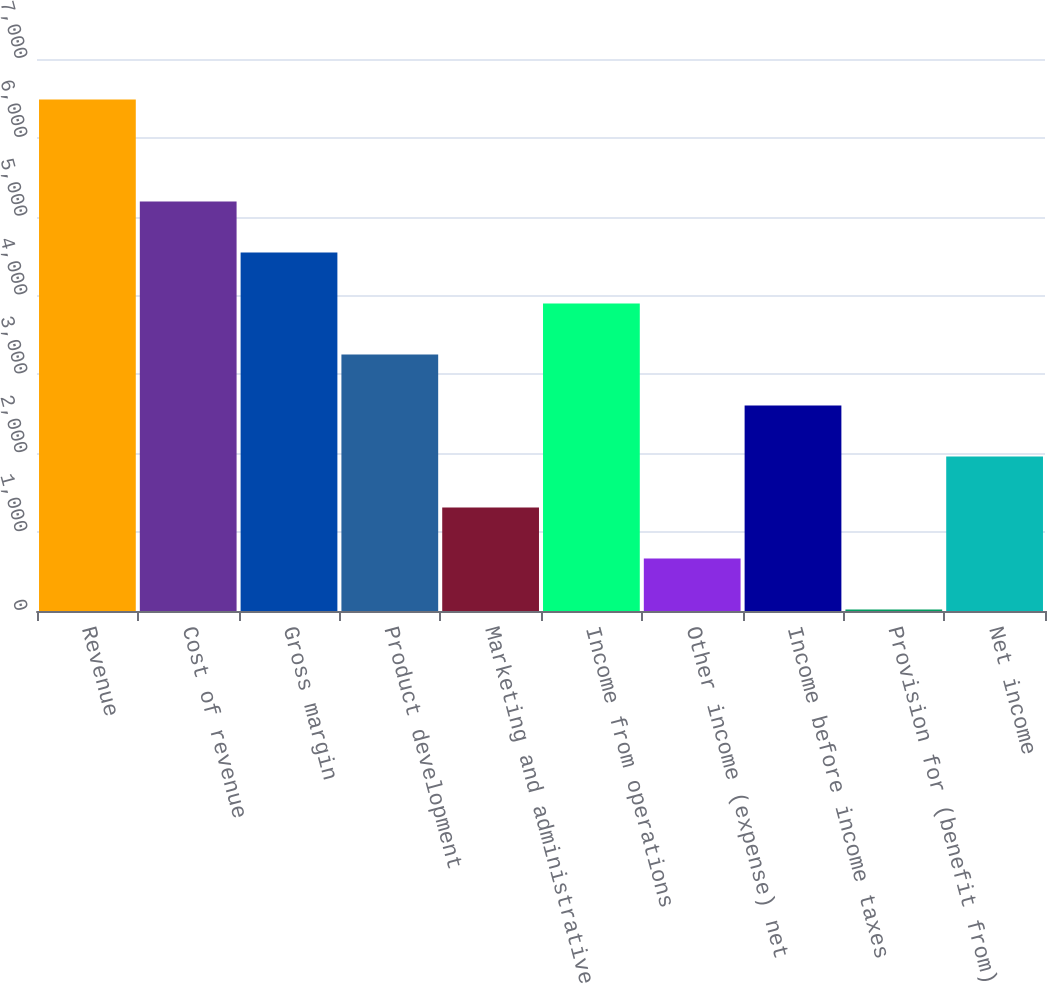Convert chart. <chart><loc_0><loc_0><loc_500><loc_500><bar_chart><fcel>Revenue<fcel>Cost of revenue<fcel>Gross margin<fcel>Product development<fcel>Marketing and administrative<fcel>Income from operations<fcel>Other income (expense) net<fcel>Income before income taxes<fcel>Provision for (benefit from)<fcel>Net income<nl><fcel>6486<fcel>5192.6<fcel>4545.9<fcel>3252.5<fcel>1312.4<fcel>3899.2<fcel>665.7<fcel>2605.8<fcel>19<fcel>1959.1<nl></chart> 